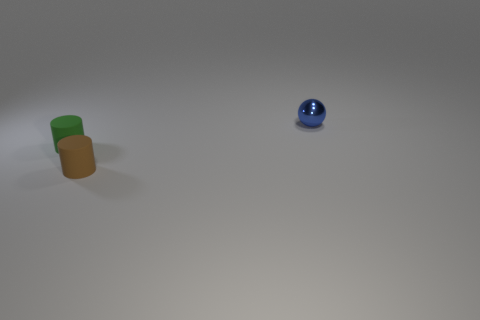Add 2 big blocks. How many objects exist? 5 Subtract all spheres. How many objects are left? 2 Subtract 0 gray cubes. How many objects are left? 3 Subtract all gray metal cylinders. Subtract all green cylinders. How many objects are left? 2 Add 3 brown things. How many brown things are left? 4 Add 2 small shiny balls. How many small shiny balls exist? 3 